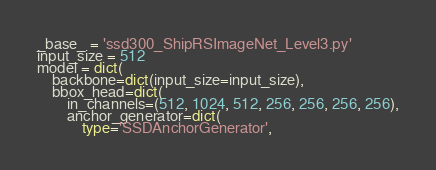<code> <loc_0><loc_0><loc_500><loc_500><_Python_>_base_ = 'ssd300_ShipRSImageNet_Level3.py'
input_size = 512
model = dict(
    backbone=dict(input_size=input_size),
    bbox_head=dict(
        in_channels=(512, 1024, 512, 256, 256, 256, 256),
        anchor_generator=dict(
            type='SSDAnchorGenerator',</code> 